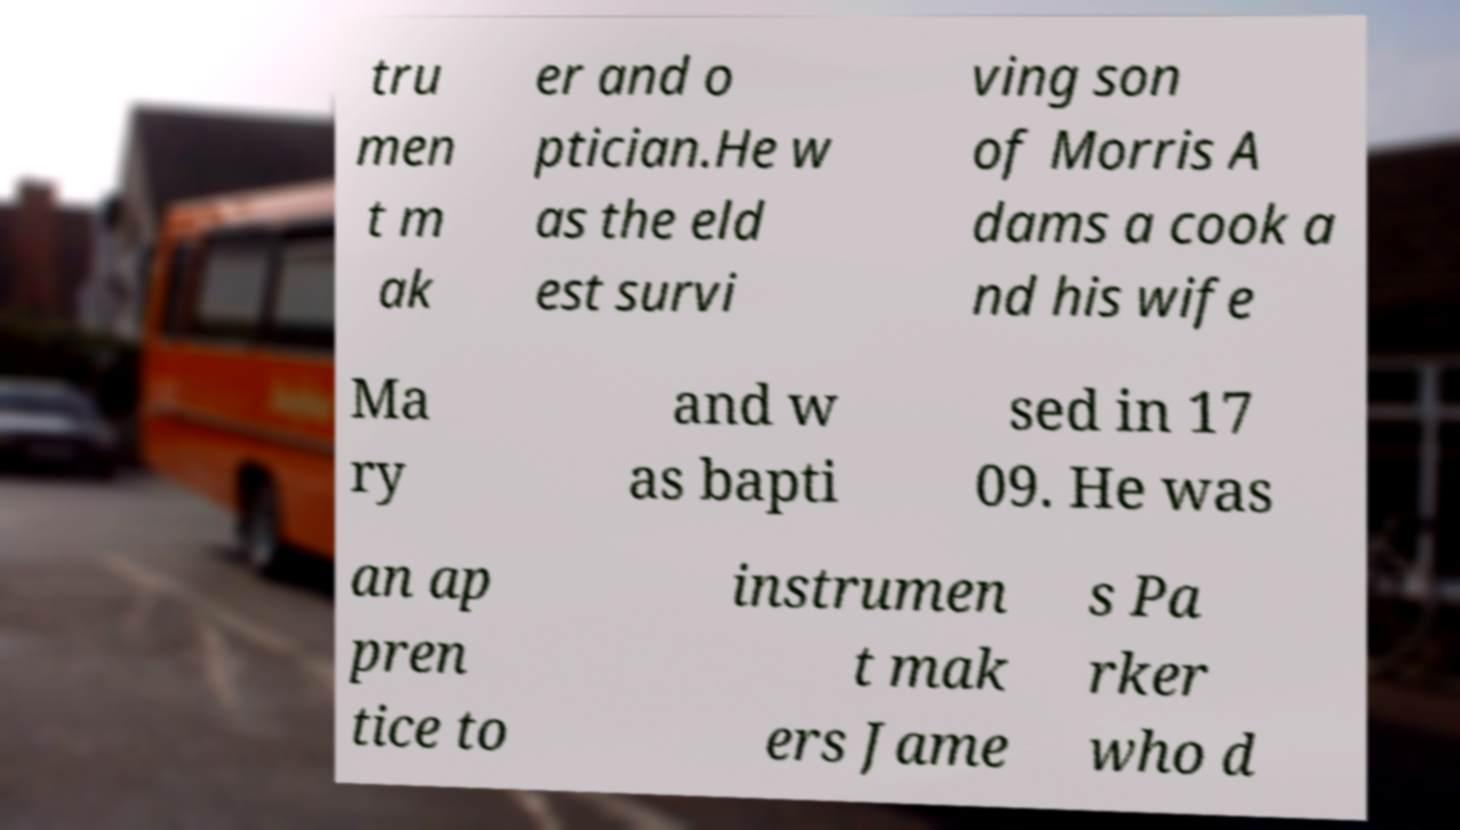Please read and relay the text visible in this image. What does it say? tru men t m ak er and o ptician.He w as the eld est survi ving son of Morris A dams a cook a nd his wife Ma ry and w as bapti sed in 17 09. He was an ap pren tice to instrumen t mak ers Jame s Pa rker who d 